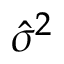Convert formula to latex. <formula><loc_0><loc_0><loc_500><loc_500>\hat { \sigma } ^ { 2 }</formula> 